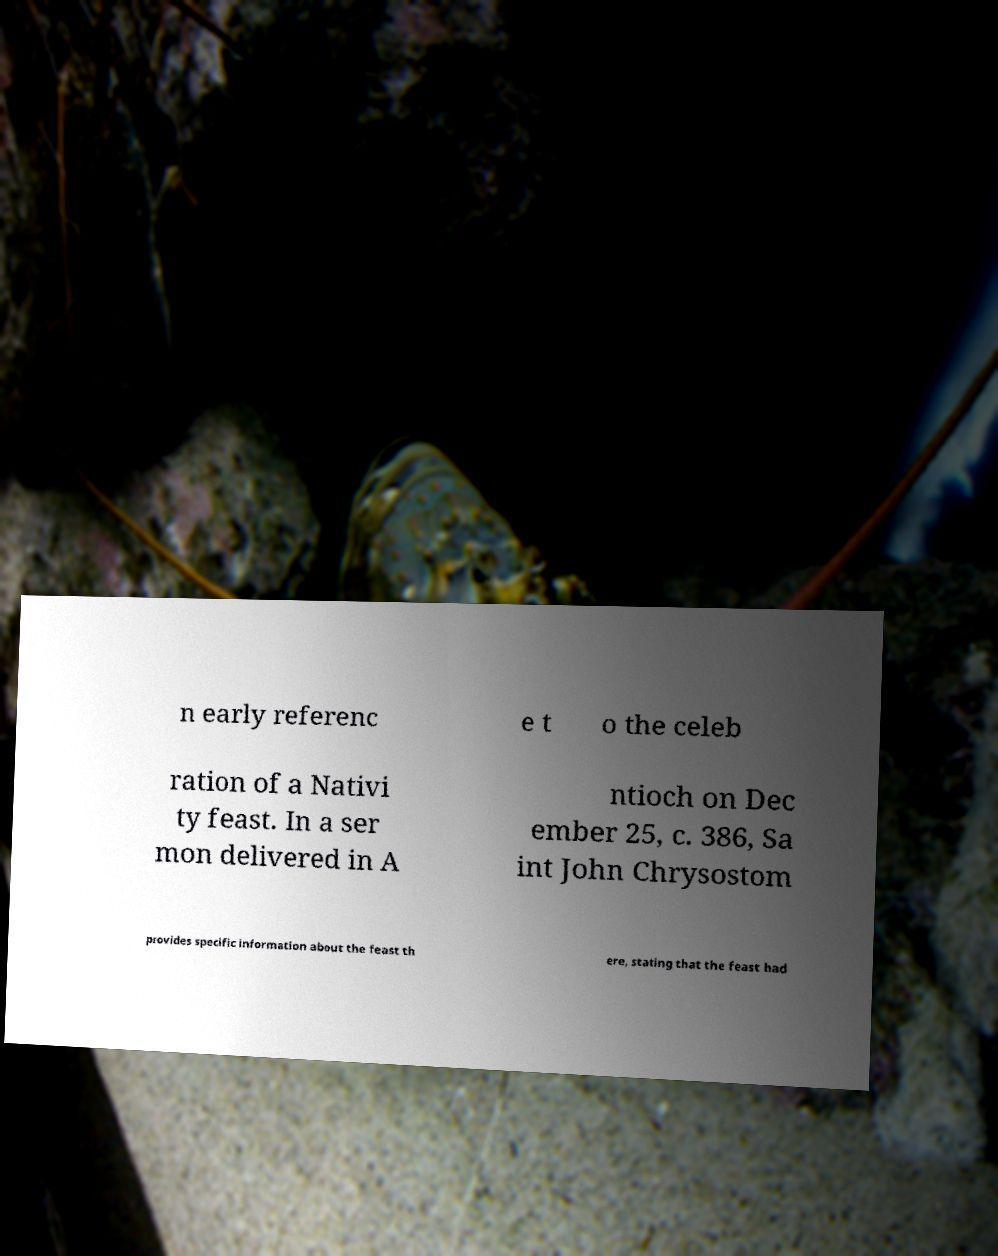There's text embedded in this image that I need extracted. Can you transcribe it verbatim? n early referenc e t o the celeb ration of a Nativi ty feast. In a ser mon delivered in A ntioch on Dec ember 25, c. 386, Sa int John Chrysostom provides specific information about the feast th ere, stating that the feast had 